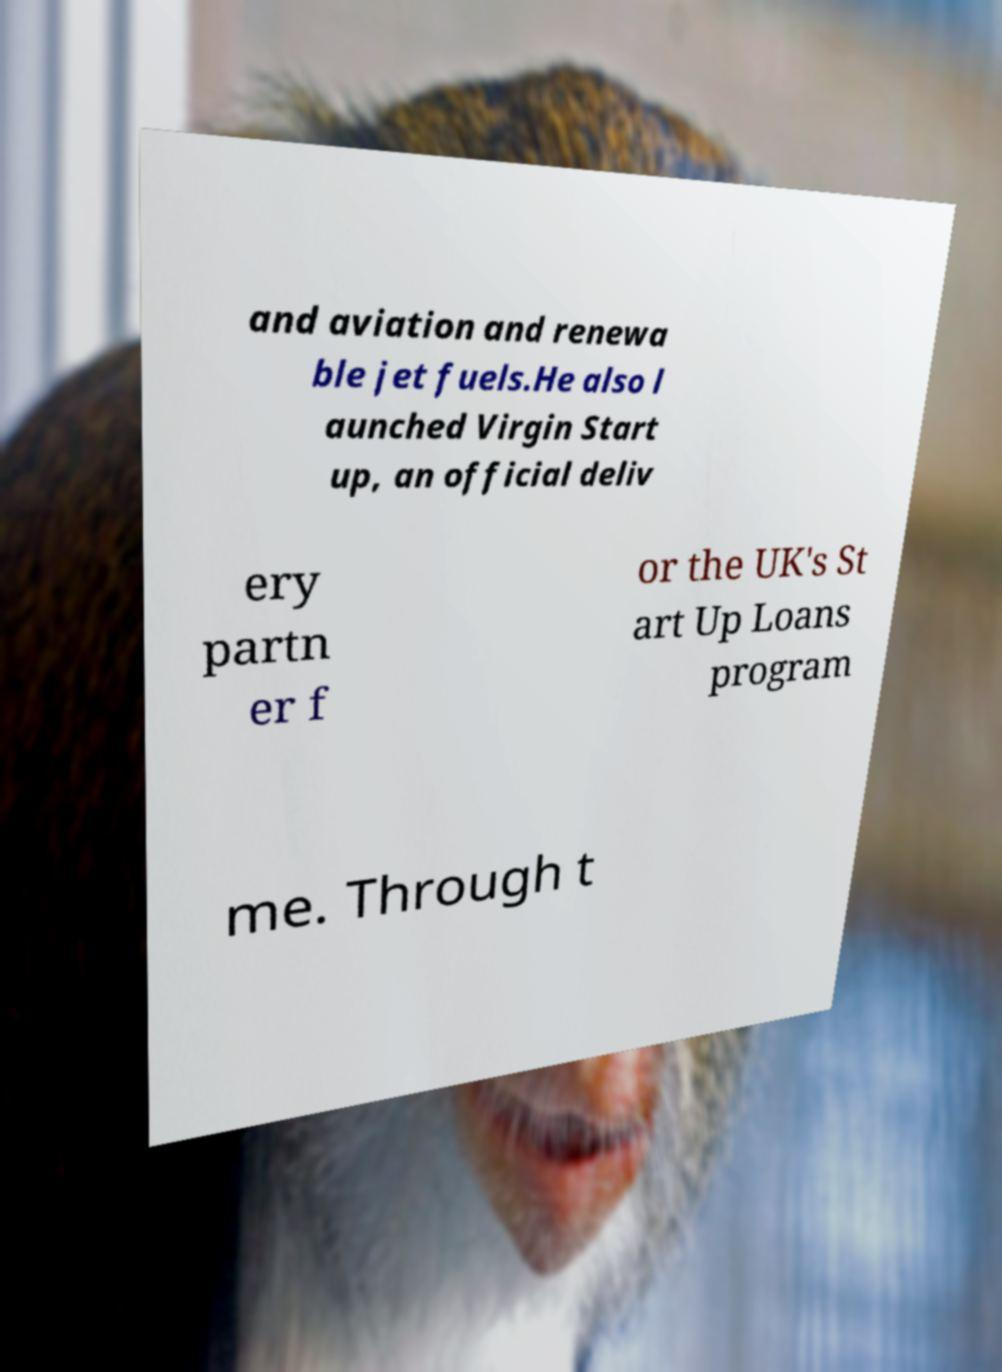Please read and relay the text visible in this image. What does it say? and aviation and renewa ble jet fuels.He also l aunched Virgin Start up, an official deliv ery partn er f or the UK's St art Up Loans program me. Through t 